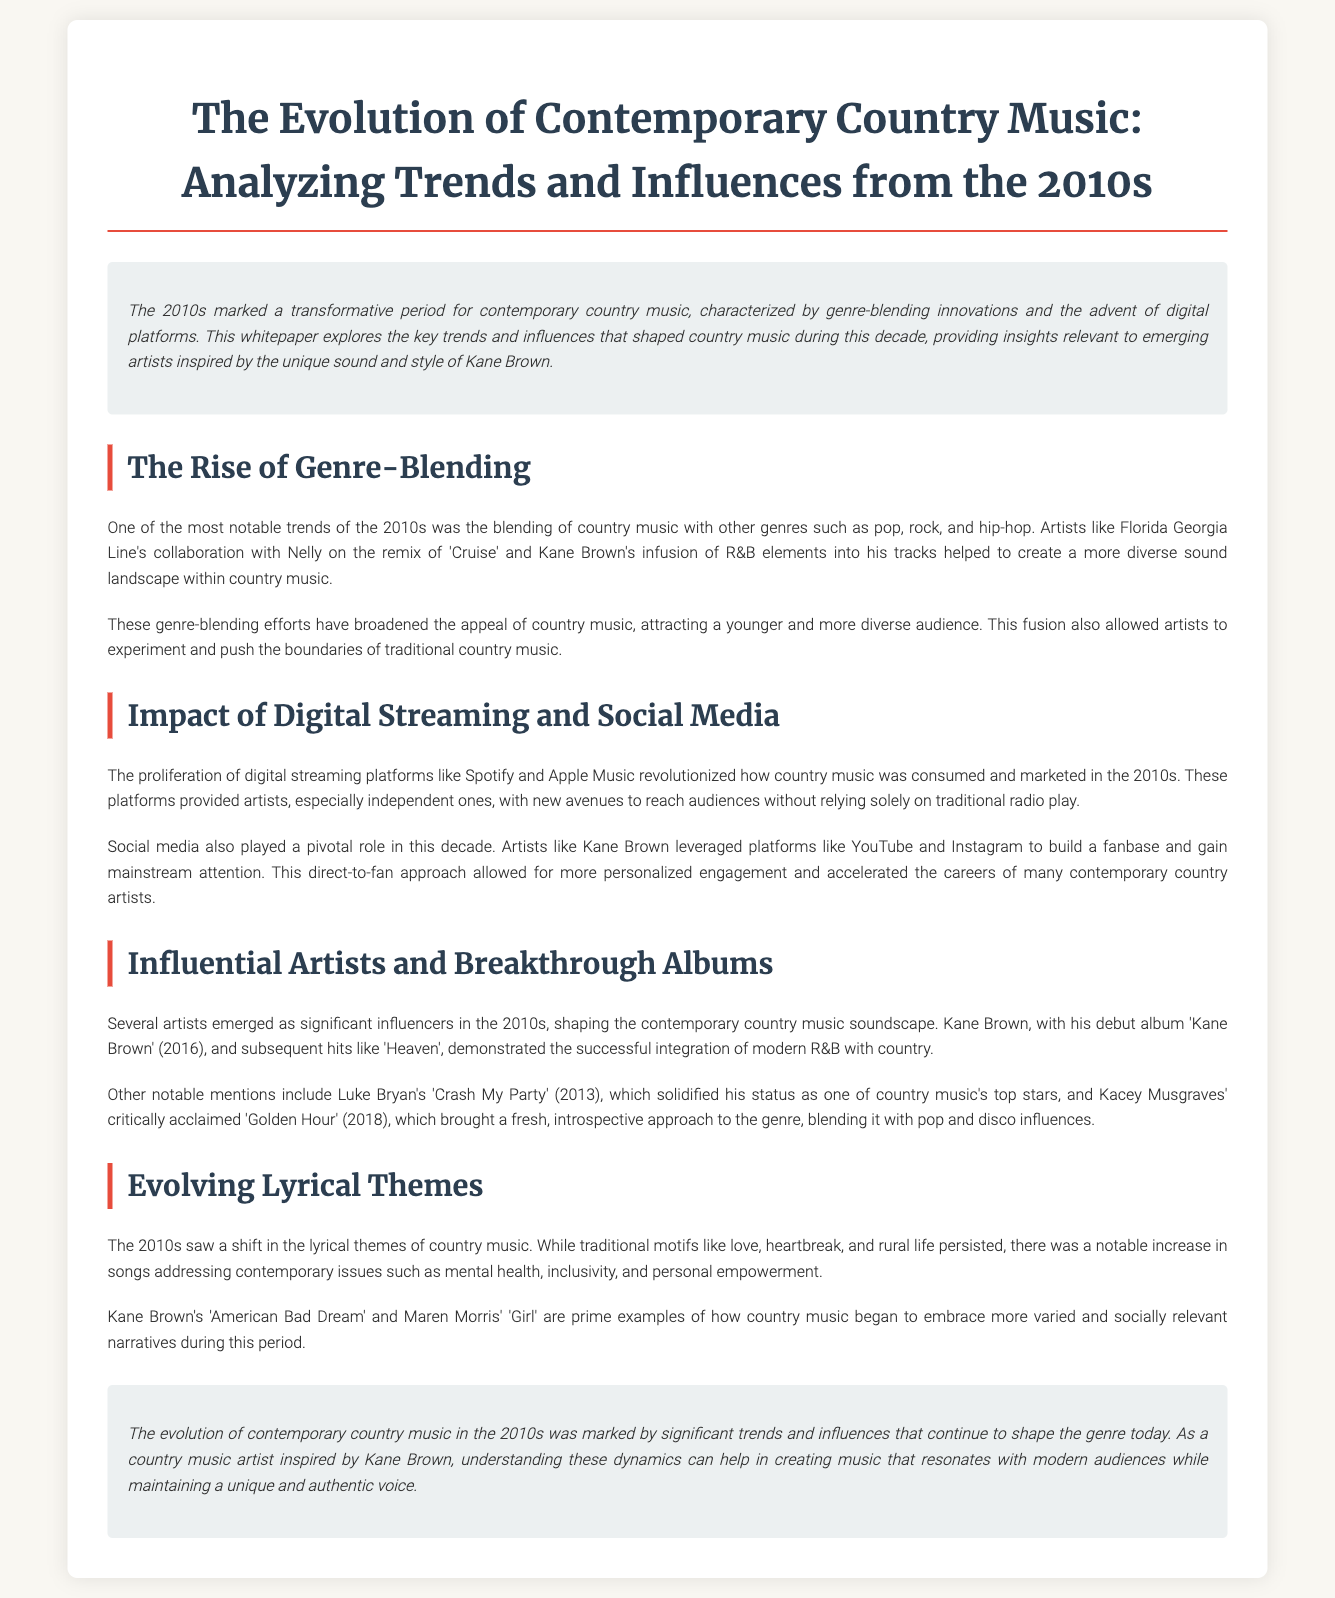What was a key trend in the 2010s for country music? The document states that one of the most notable trends was the blending of country music with other genres.
Answer: Genre-blending Who collaborated with Florida Georgia Line on the remix of 'Cruise'? The document mentions Nelly as the collaborator on the remix of 'Cruise'.
Answer: Nelly What percentage of music consumption shifted to digital platforms in the 2010s? The document does not provide a percentage; it discusses the transition in a qualitative way.
Answer: Not specified Which album by Kane Brown was released in 2016? The document states that Kane Brown's debut album was titled 'Kane Brown'.
Answer: Kane Brown What notable theme did country music embrace more in the 2010s? The document highlights the increase in addressing contemporary issues such as mental health and inclusivity.
Answer: Contemporary issues Which platform significantly impacted how country music was marketed in the 2010s? The document points out that digital streaming platforms like Spotify revolutionized music consumption and marketing.
Answer: Streaming platforms What significant lyrical theme is mentioned related to Kane Brown's song 'American Bad Dream'? The song addresses contemporary themes such as personal empowerment.
Answer: Personal empowerment Which album by Kacey Musgraves is mentioned in the document? The document refers to Kacey Musgraves' album 'Golden Hour', released in 2018.
Answer: Golden Hour What was the primary focus of the whitepaper? The document discusses the transformative period and trends in contemporary country music during the 2010s.
Answer: Trends and influences 